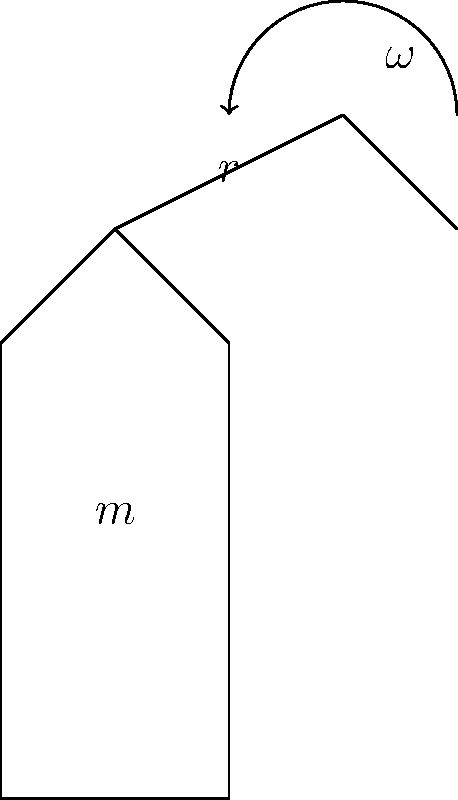During a tennis serve at the Australian Open, a player's arm and racket can be modeled as a rigid rod rotating about the shoulder. If the combined mass of the arm and racket is 4 kg, the center of mass is 0.6 m from the shoulder, and the angular velocity at the point of contact with the ball is 25 rad/s, what is the magnitude of the angular momentum of the arm-racket system? To solve this problem, we'll use the formula for angular momentum of a rotating rigid body:

$$L = I\omega$$

Where:
$L$ = angular momentum
$I$ = moment of inertia
$\omega$ = angular velocity

For a rod rotating about one end, the moment of inertia is given by:

$$I = \frac{1}{3}mr^2$$

Where:
$m$ = mass of the rod
$r$ = length of the rod

Step 1: Calculate the moment of inertia
$$I = \frac{1}{3} \times 4 \text{ kg} \times (0.6 \text{ m})^2 = 0.48 \text{ kg}\cdot\text{m}^2$$

Step 2: Calculate the angular momentum
$$L = I\omega = 0.48 \text{ kg}\cdot\text{m}^2 \times 25 \text{ rad/s} = 12 \text{ kg}\cdot\text{m}^2/\text{s}$$

Therefore, the magnitude of the angular momentum is 12 kg⋅m²/s.
Answer: 12 kg⋅m²/s 